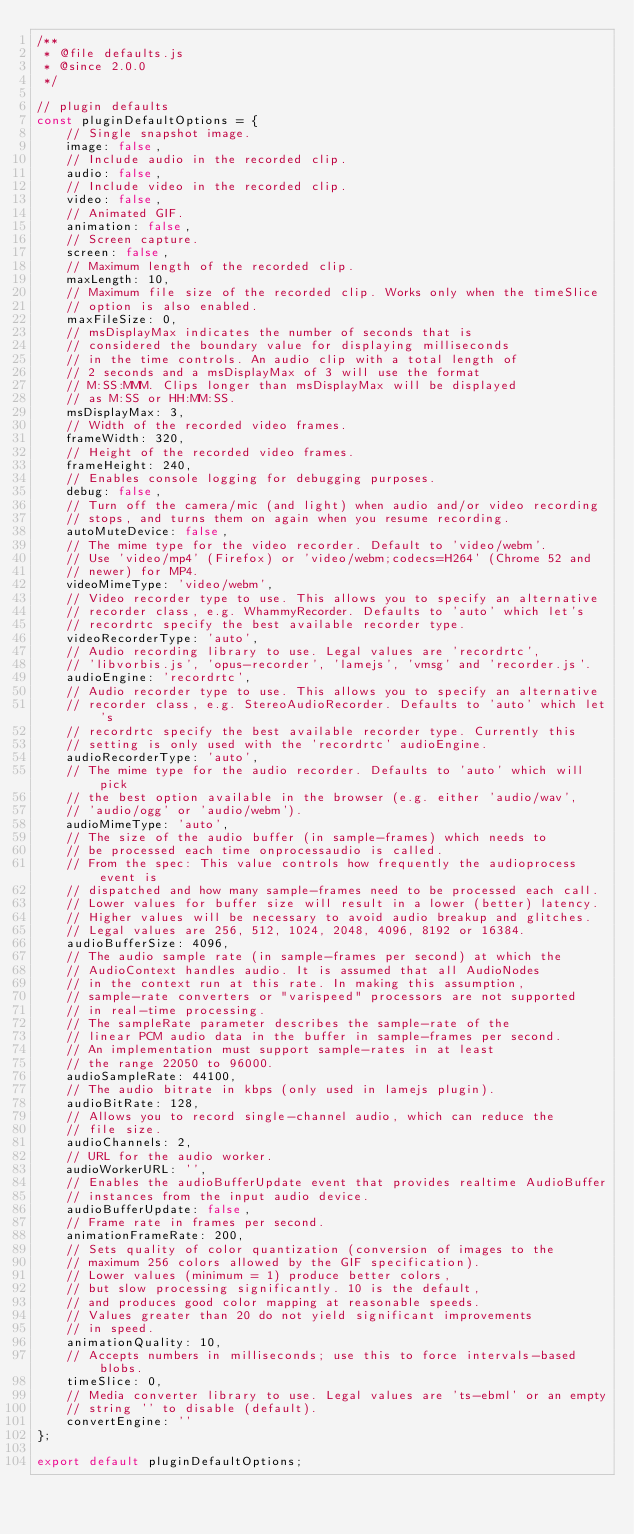<code> <loc_0><loc_0><loc_500><loc_500><_JavaScript_>/**
 * @file defaults.js
 * @since 2.0.0
 */

// plugin defaults
const pluginDefaultOptions = {
    // Single snapshot image.
    image: false,
    // Include audio in the recorded clip.
    audio: false,
    // Include video in the recorded clip.
    video: false,
    // Animated GIF.
    animation: false,
    // Screen capture.
    screen: false,
    // Maximum length of the recorded clip.
    maxLength: 10,
    // Maximum file size of the recorded clip. Works only when the timeSlice
    // option is also enabled.
    maxFileSize: 0,
    // msDisplayMax indicates the number of seconds that is
    // considered the boundary value for displaying milliseconds
    // in the time controls. An audio clip with a total length of
    // 2 seconds and a msDisplayMax of 3 will use the format
    // M:SS:MMM. Clips longer than msDisplayMax will be displayed
    // as M:SS or HH:MM:SS.
    msDisplayMax: 3,
    // Width of the recorded video frames.
    frameWidth: 320,
    // Height of the recorded video frames.
    frameHeight: 240,
    // Enables console logging for debugging purposes.
    debug: false,
    // Turn off the camera/mic (and light) when audio and/or video recording
    // stops, and turns them on again when you resume recording.
    autoMuteDevice: false,
    // The mime type for the video recorder. Default to 'video/webm'.
    // Use 'video/mp4' (Firefox) or 'video/webm;codecs=H264' (Chrome 52 and
    // newer) for MP4.
    videoMimeType: 'video/webm',
    // Video recorder type to use. This allows you to specify an alternative
    // recorder class, e.g. WhammyRecorder. Defaults to 'auto' which let's
    // recordrtc specify the best available recorder type.
    videoRecorderType: 'auto',
    // Audio recording library to use. Legal values are 'recordrtc',
    // 'libvorbis.js', 'opus-recorder', 'lamejs', 'vmsg' and 'recorder.js'.
    audioEngine: 'recordrtc',
    // Audio recorder type to use. This allows you to specify an alternative
    // recorder class, e.g. StereoAudioRecorder. Defaults to 'auto' which let's
    // recordrtc specify the best available recorder type. Currently this
    // setting is only used with the 'recordrtc' audioEngine.
    audioRecorderType: 'auto',
    // The mime type for the audio recorder. Defaults to 'auto' which will pick
    // the best option available in the browser (e.g. either 'audio/wav',
    // 'audio/ogg' or 'audio/webm').
    audioMimeType: 'auto',
    // The size of the audio buffer (in sample-frames) which needs to
    // be processed each time onprocessaudio is called.
    // From the spec: This value controls how frequently the audioprocess event is
    // dispatched and how many sample-frames need to be processed each call.
    // Lower values for buffer size will result in a lower (better) latency.
    // Higher values will be necessary to avoid audio breakup and glitches.
    // Legal values are 256, 512, 1024, 2048, 4096, 8192 or 16384.
    audioBufferSize: 4096,
    // The audio sample rate (in sample-frames per second) at which the
    // AudioContext handles audio. It is assumed that all AudioNodes
    // in the context run at this rate. In making this assumption,
    // sample-rate converters or "varispeed" processors are not supported
    // in real-time processing.
    // The sampleRate parameter describes the sample-rate of the
    // linear PCM audio data in the buffer in sample-frames per second.
    // An implementation must support sample-rates in at least
    // the range 22050 to 96000.
    audioSampleRate: 44100,
    // The audio bitrate in kbps (only used in lamejs plugin).
    audioBitRate: 128,
    // Allows you to record single-channel audio, which can reduce the
    // file size.
    audioChannels: 2,
    // URL for the audio worker.
    audioWorkerURL: '',
    // Enables the audioBufferUpdate event that provides realtime AudioBuffer
    // instances from the input audio device.
    audioBufferUpdate: false,
    // Frame rate in frames per second.
    animationFrameRate: 200,
    // Sets quality of color quantization (conversion of images to the
    // maximum 256 colors allowed by the GIF specification).
    // Lower values (minimum = 1) produce better colors,
    // but slow processing significantly. 10 is the default,
    // and produces good color mapping at reasonable speeds.
    // Values greater than 20 do not yield significant improvements
    // in speed.
    animationQuality: 10,
    // Accepts numbers in milliseconds; use this to force intervals-based blobs.
    timeSlice: 0,
    // Media converter library to use. Legal values are 'ts-ebml' or an empty
    // string '' to disable (default).
    convertEngine: ''
};

export default pluginDefaultOptions;
</code> 